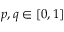Convert formula to latex. <formula><loc_0><loc_0><loc_500><loc_500>p , q \in [ 0 , 1 ]</formula> 